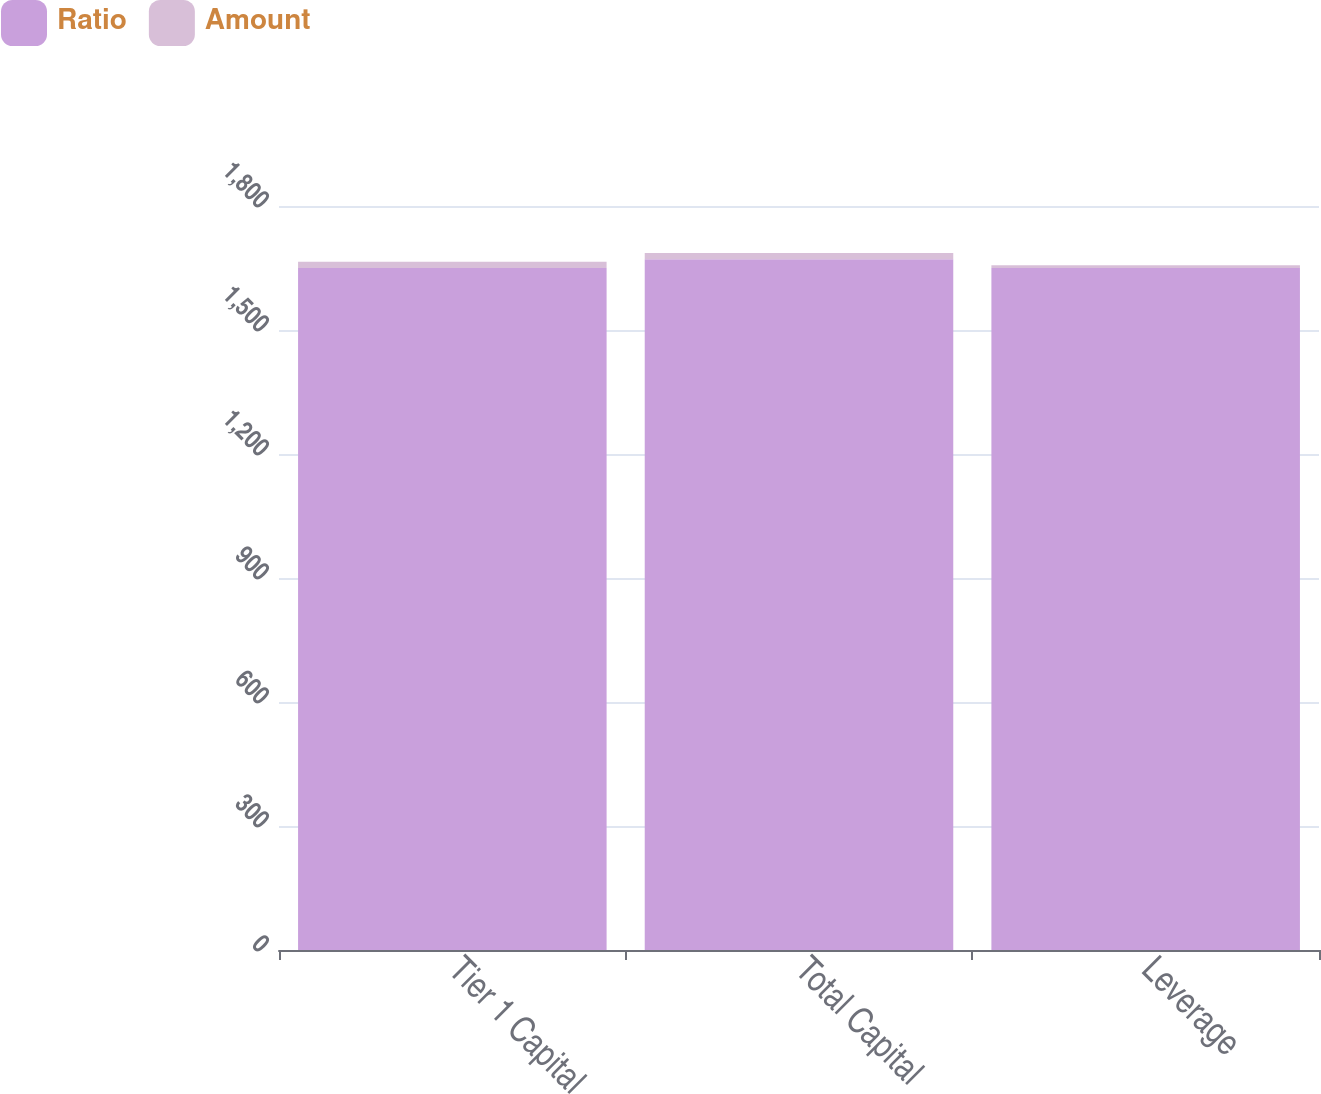<chart> <loc_0><loc_0><loc_500><loc_500><stacked_bar_chart><ecel><fcel>Tier 1 Capital<fcel>Total Capital<fcel>Leverage<nl><fcel>Ratio<fcel>1650<fcel>1671<fcel>1650<nl><fcel>Amount<fcel>15.3<fcel>15.5<fcel>6.4<nl></chart> 